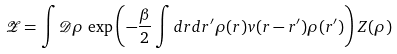<formula> <loc_0><loc_0><loc_500><loc_500>\mathcal { Z } = \int \mathcal { D } \rho \, \exp \left ( - \frac { \beta } { 2 } \int d r d r ^ { \prime } \rho ( r ) v ( r - r ^ { \prime } ) \rho ( r ^ { \prime } ) \right ) Z ( \rho )</formula> 